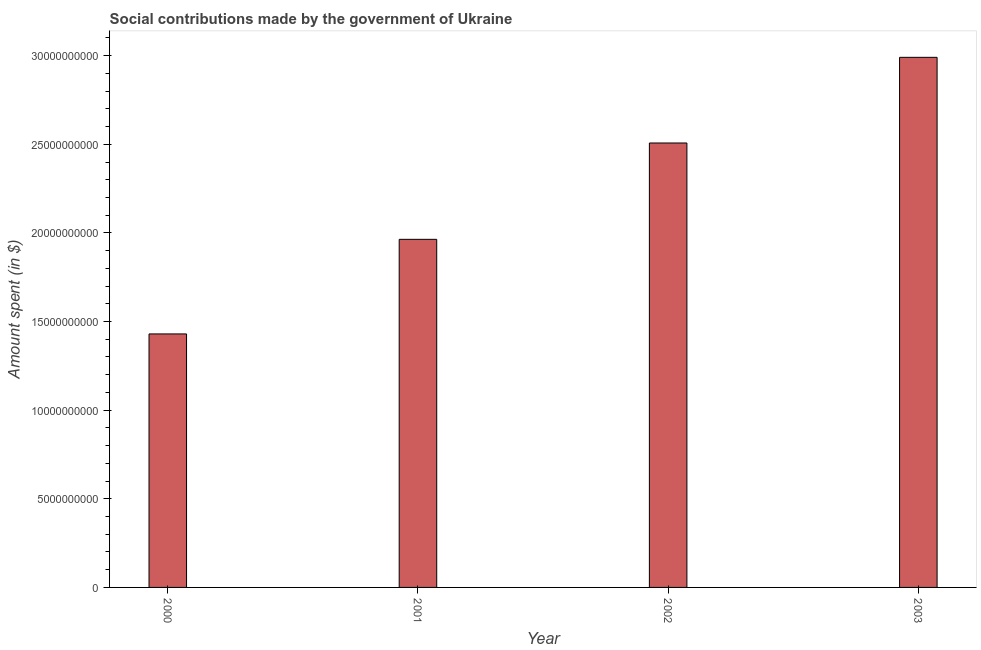What is the title of the graph?
Keep it short and to the point. Social contributions made by the government of Ukraine. What is the label or title of the Y-axis?
Give a very brief answer. Amount spent (in $). What is the amount spent in making social contributions in 2003?
Your answer should be compact. 2.99e+1. Across all years, what is the maximum amount spent in making social contributions?
Provide a succinct answer. 2.99e+1. Across all years, what is the minimum amount spent in making social contributions?
Keep it short and to the point. 1.43e+1. In which year was the amount spent in making social contributions maximum?
Make the answer very short. 2003. In which year was the amount spent in making social contributions minimum?
Your answer should be compact. 2000. What is the sum of the amount spent in making social contributions?
Provide a succinct answer. 8.89e+1. What is the difference between the amount spent in making social contributions in 2001 and 2002?
Your response must be concise. -5.44e+09. What is the average amount spent in making social contributions per year?
Your response must be concise. 2.22e+1. What is the median amount spent in making social contributions?
Make the answer very short. 2.24e+1. Do a majority of the years between 2003 and 2000 (inclusive) have amount spent in making social contributions greater than 9000000000 $?
Provide a succinct answer. Yes. What is the ratio of the amount spent in making social contributions in 2002 to that in 2003?
Provide a succinct answer. 0.84. What is the difference between the highest and the second highest amount spent in making social contributions?
Keep it short and to the point. 4.83e+09. Is the sum of the amount spent in making social contributions in 2001 and 2002 greater than the maximum amount spent in making social contributions across all years?
Offer a terse response. Yes. What is the difference between the highest and the lowest amount spent in making social contributions?
Make the answer very short. 1.56e+1. Are all the bars in the graph horizontal?
Offer a terse response. No. How many years are there in the graph?
Ensure brevity in your answer.  4. What is the difference between two consecutive major ticks on the Y-axis?
Offer a very short reply. 5.00e+09. What is the Amount spent (in $) of 2000?
Give a very brief answer. 1.43e+1. What is the Amount spent (in $) in 2001?
Offer a very short reply. 1.96e+1. What is the Amount spent (in $) in 2002?
Keep it short and to the point. 2.51e+1. What is the Amount spent (in $) of 2003?
Make the answer very short. 2.99e+1. What is the difference between the Amount spent (in $) in 2000 and 2001?
Keep it short and to the point. -5.34e+09. What is the difference between the Amount spent (in $) in 2000 and 2002?
Provide a succinct answer. -1.08e+1. What is the difference between the Amount spent (in $) in 2000 and 2003?
Make the answer very short. -1.56e+1. What is the difference between the Amount spent (in $) in 2001 and 2002?
Offer a terse response. -5.44e+09. What is the difference between the Amount spent (in $) in 2001 and 2003?
Offer a terse response. -1.03e+1. What is the difference between the Amount spent (in $) in 2002 and 2003?
Offer a terse response. -4.83e+09. What is the ratio of the Amount spent (in $) in 2000 to that in 2001?
Ensure brevity in your answer.  0.73. What is the ratio of the Amount spent (in $) in 2000 to that in 2002?
Your answer should be compact. 0.57. What is the ratio of the Amount spent (in $) in 2000 to that in 2003?
Your response must be concise. 0.48. What is the ratio of the Amount spent (in $) in 2001 to that in 2002?
Give a very brief answer. 0.78. What is the ratio of the Amount spent (in $) in 2001 to that in 2003?
Provide a succinct answer. 0.66. What is the ratio of the Amount spent (in $) in 2002 to that in 2003?
Offer a terse response. 0.84. 